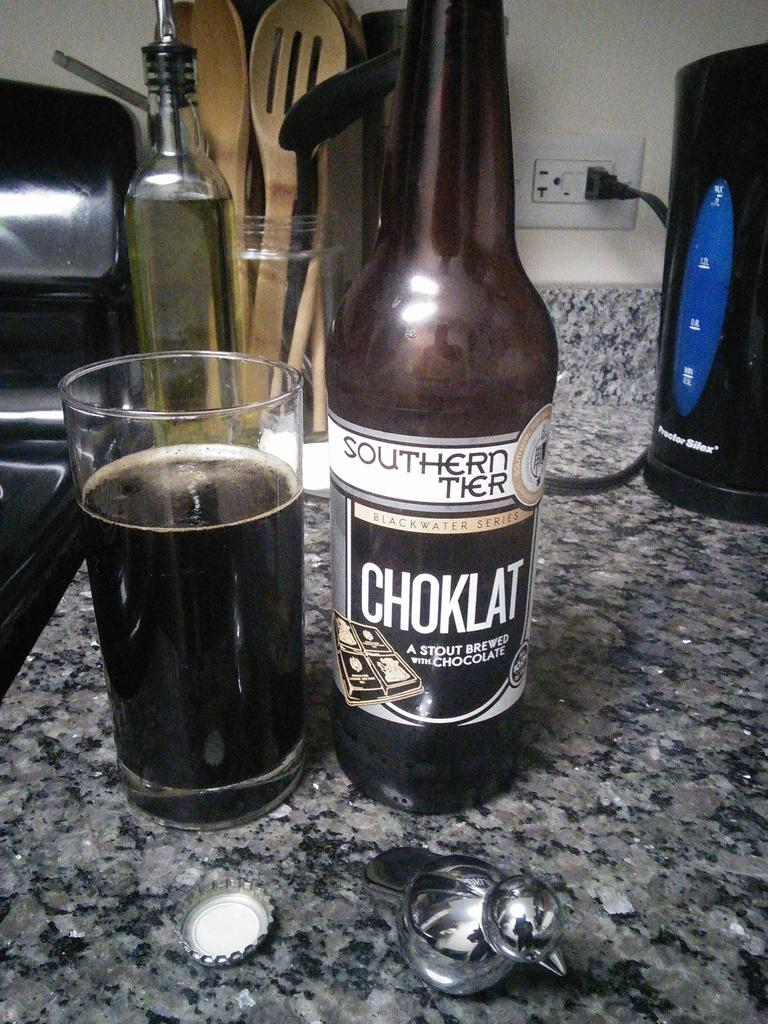<image>
Create a compact narrative representing the image presented. A bottle of Choklat has been opened and is sitting on the counter. 